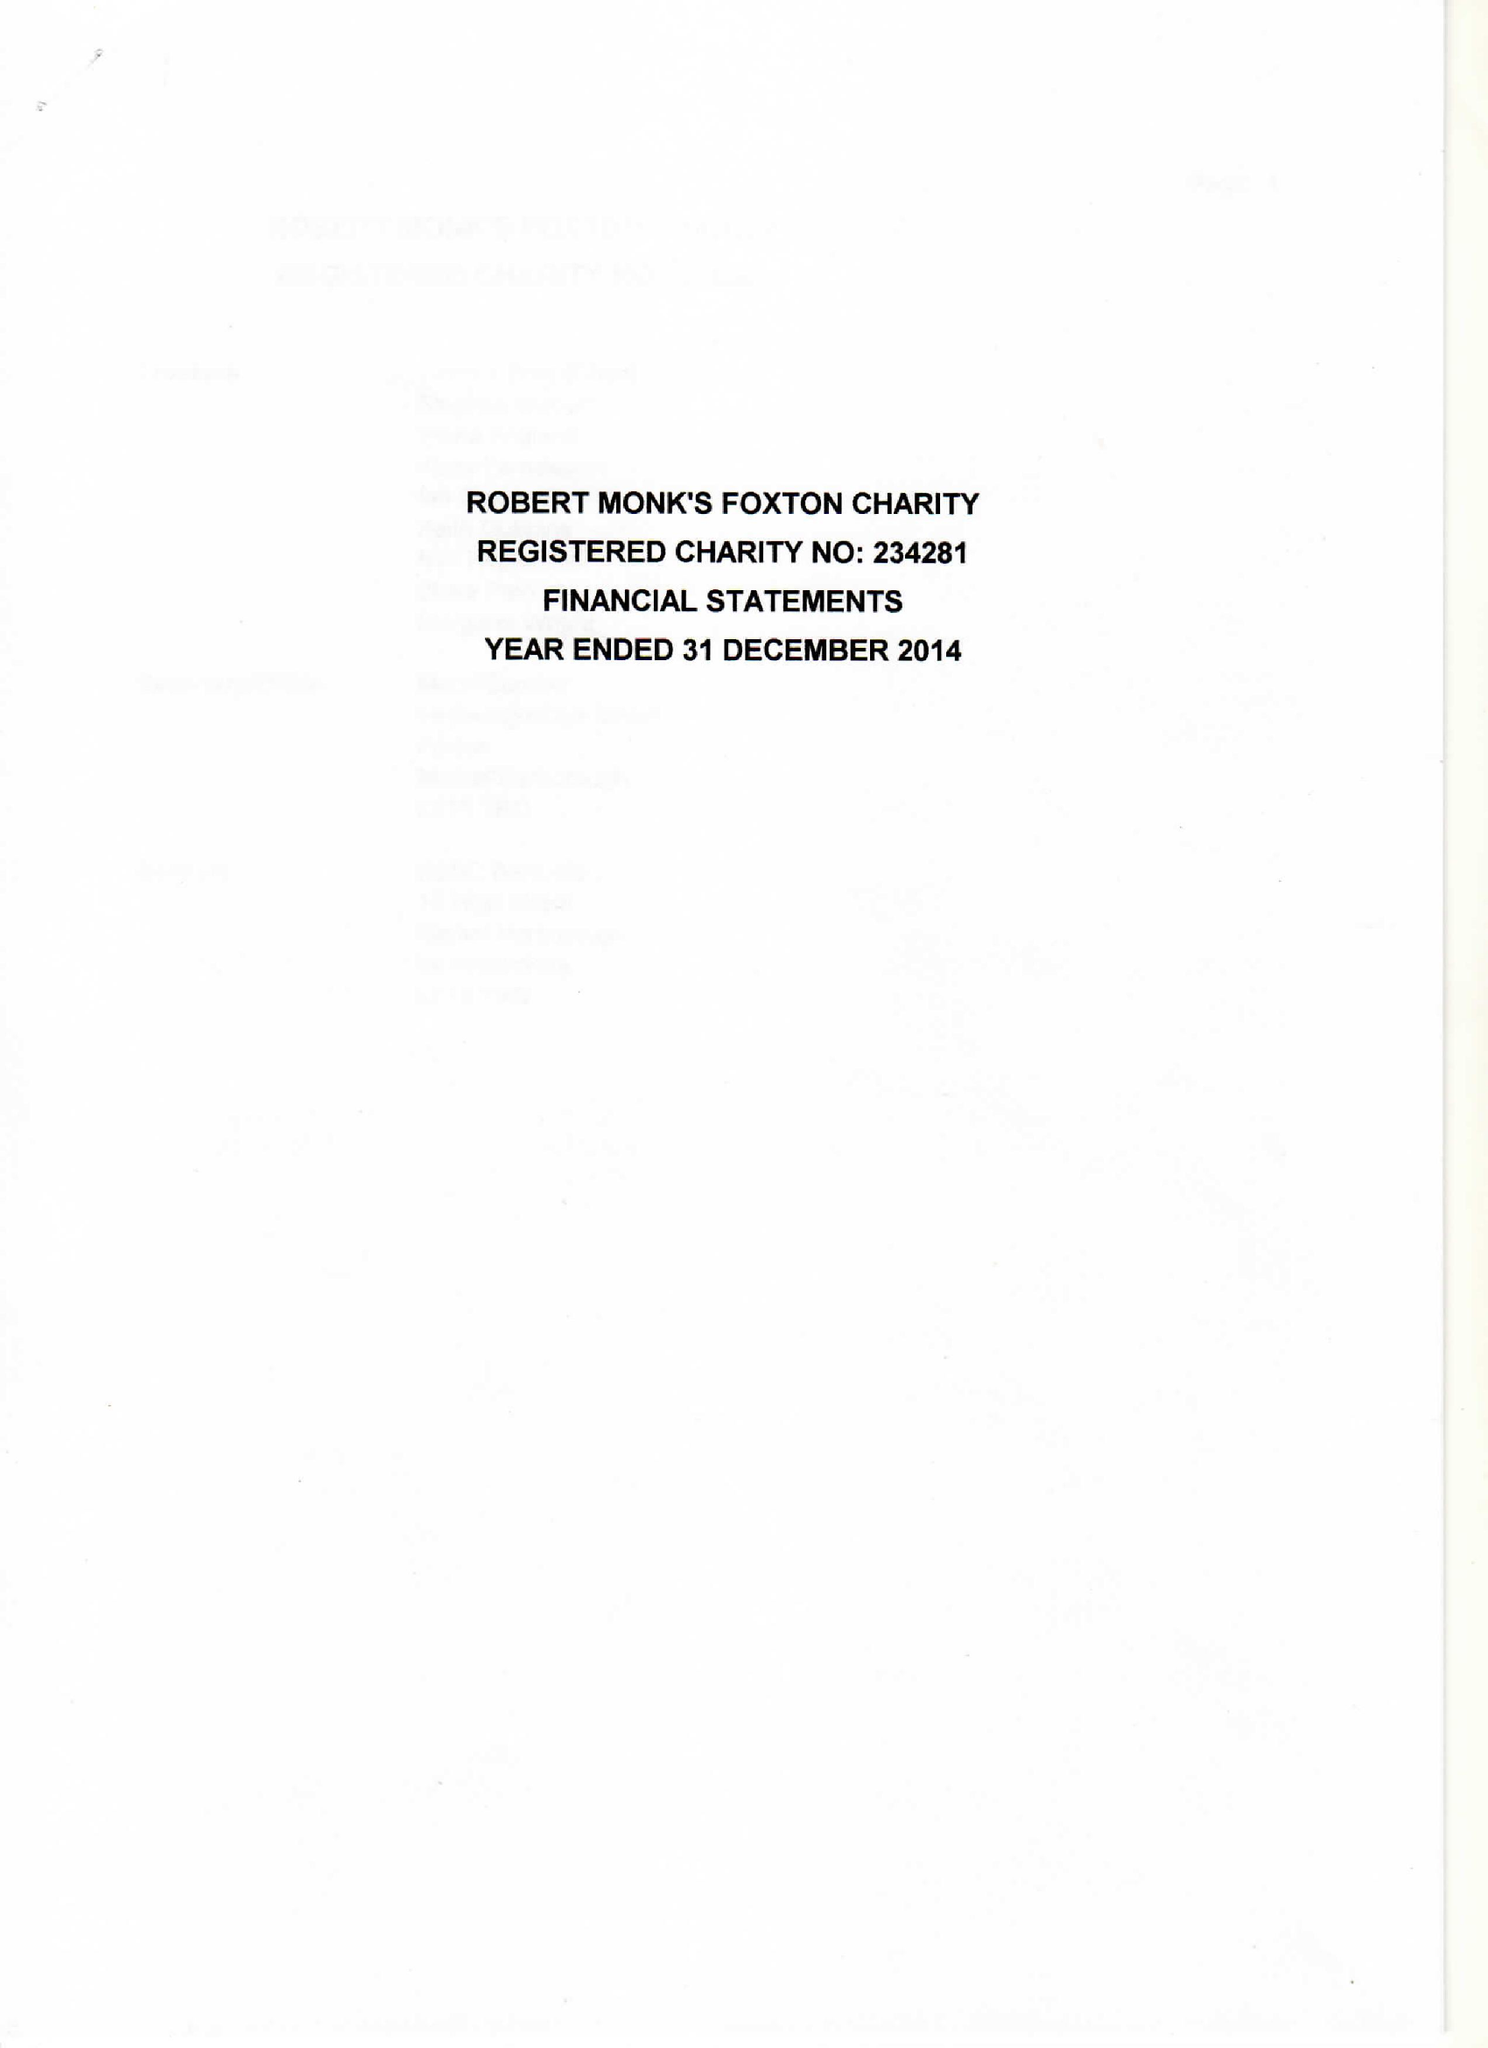What is the value for the address__street_line?
Answer the question using a single word or phrase. 49 MIDDLE STREET 